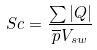Convert formula to latex. <formula><loc_0><loc_0><loc_500><loc_500>S c = \frac { \sum | Q | } { \overline { p } V _ { s w } }</formula> 